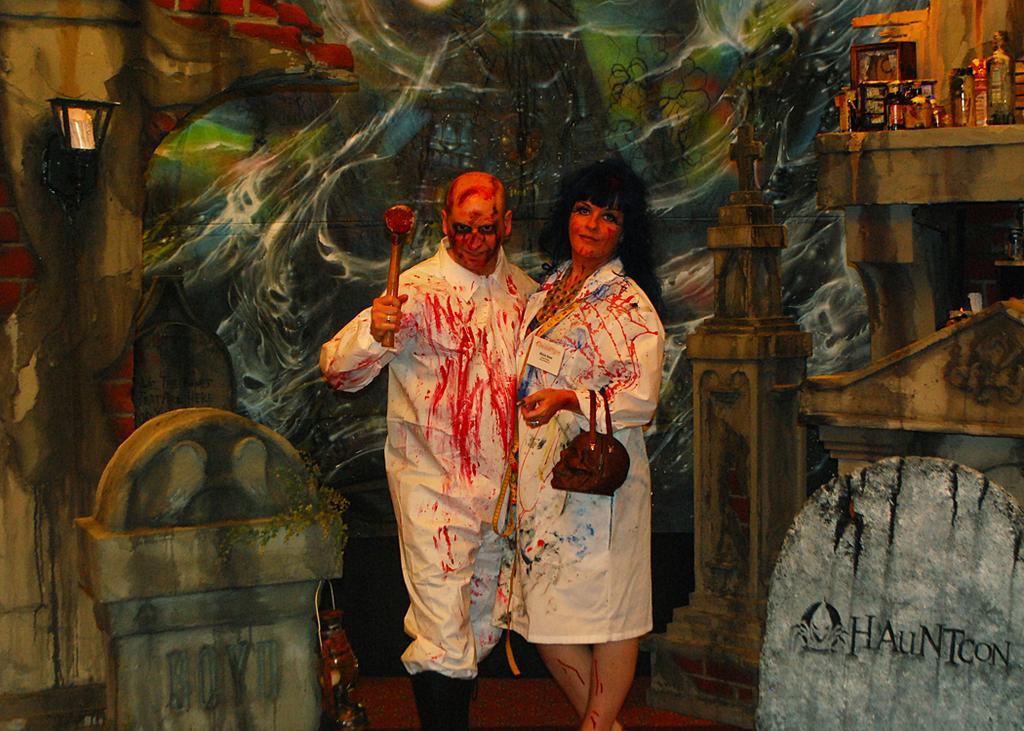In one or two sentences, can you explain what this image depicts? In this image we can see a man and a woman with a costume. Woman is holding a bag and man is holding some other thing. In the back there is a wall with a painting. On the right side there is an object with a text. And there are few other things. 